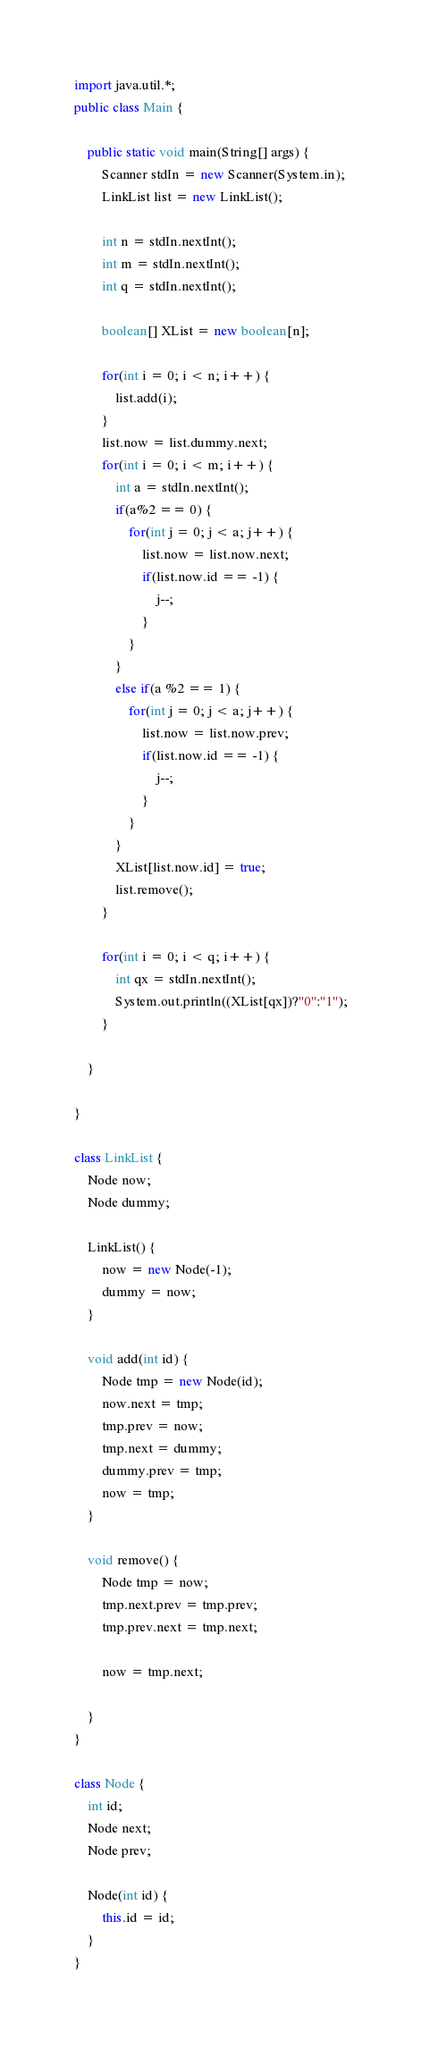<code> <loc_0><loc_0><loc_500><loc_500><_Java_>import java.util.*;
public class Main {

	public static void main(String[] args) {
		Scanner stdIn = new Scanner(System.in);
		LinkList list = new LinkList();
		
		int n = stdIn.nextInt();
		int m = stdIn.nextInt();
		int q = stdIn.nextInt();
		
		boolean[] XList = new boolean[n];
		
		for(int i = 0; i < n; i++) {
			list.add(i);
		}
		list.now = list.dummy.next;
		for(int i = 0; i < m; i++) {
			int a = stdIn.nextInt();
			if(a%2 == 0) {
				for(int j = 0; j < a; j++) {
					list.now = list.now.next;
					if(list.now.id == -1) {
						j--;
					}
				}
			}
			else if(a %2 == 1) {
				for(int j = 0; j < a; j++) {
					list.now = list.now.prev;
					if(list.now.id == -1) {
						j--;
					}
				}
			}
			XList[list.now.id] = true;
			list.remove();
		}
		
		for(int i = 0; i < q; i++) {
			int qx = stdIn.nextInt();
			System.out.println((XList[qx])?"0":"1");
		}
		
	}

}

class LinkList {
	Node now;
	Node dummy;

	LinkList() {
		now = new Node(-1);
		dummy = now;
	}
	
	void add(int id) {
		Node tmp = new Node(id);
		now.next = tmp;
		tmp.prev = now;
		tmp.next = dummy;
		dummy.prev = tmp;
		now = tmp;
	}
	
	void remove() {
		Node tmp = now;
		tmp.next.prev = tmp.prev;
		tmp.prev.next = tmp.next;
		
		now = tmp.next;
		
	}
}

class Node {
	int id;
	Node next;
	Node prev;
	
	Node(int id) {
		this.id = id;
	}
}</code> 